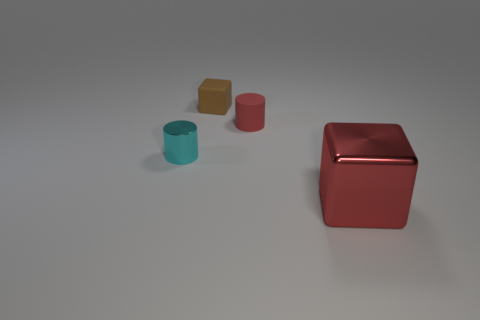What might be the purpose of this image? The image could serve various purposes; it looks like a simple composition that might be used to demonstrate color contrast, object size comparison, or as a visual element in a minimalist graphic design. 